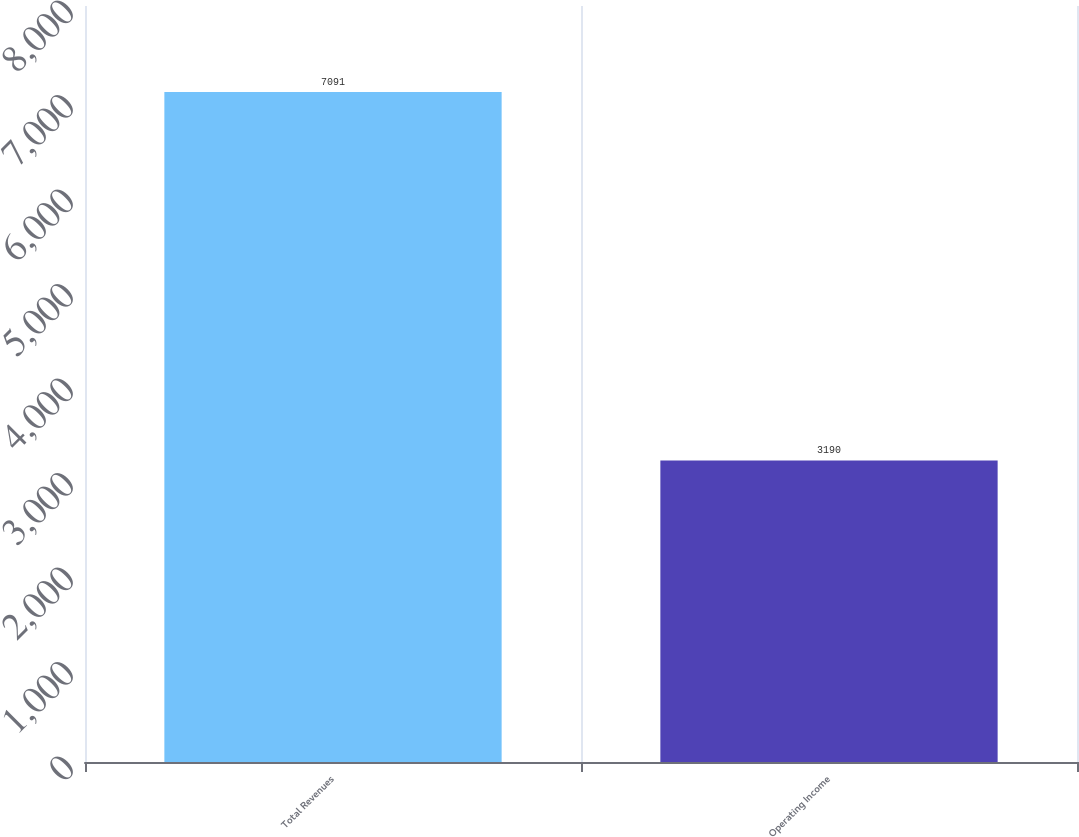Convert chart to OTSL. <chart><loc_0><loc_0><loc_500><loc_500><bar_chart><fcel>Total Revenues<fcel>Operating Income<nl><fcel>7091<fcel>3190<nl></chart> 